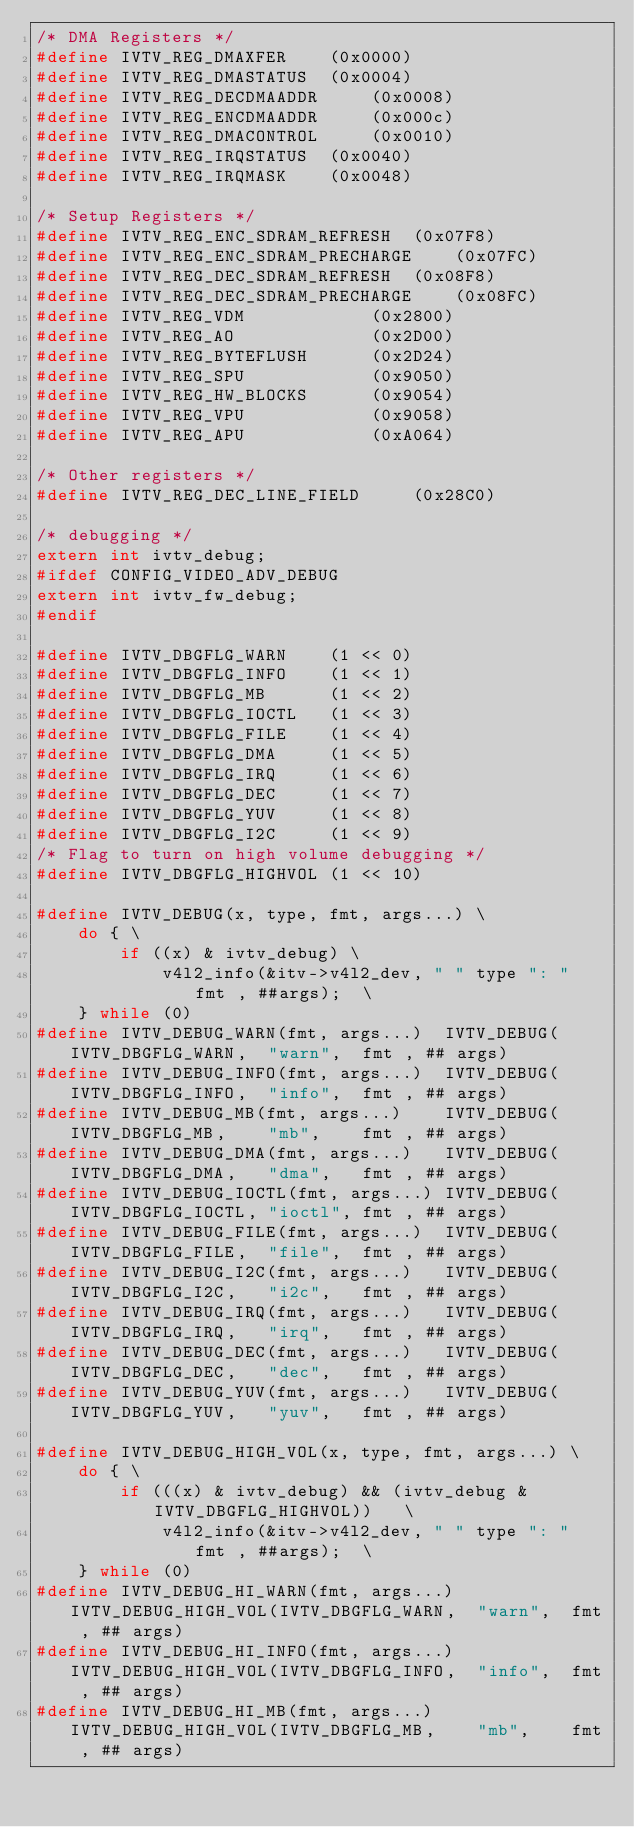Convert code to text. <code><loc_0><loc_0><loc_500><loc_500><_C_>/* DMA Registers */
#define IVTV_REG_DMAXFER 	(0x0000)
#define IVTV_REG_DMASTATUS 	(0x0004)
#define IVTV_REG_DECDMAADDR 	(0x0008)
#define IVTV_REG_ENCDMAADDR 	(0x000c)
#define IVTV_REG_DMACONTROL 	(0x0010)
#define IVTV_REG_IRQSTATUS 	(0x0040)
#define IVTV_REG_IRQMASK 	(0x0048)

/* Setup Registers */
#define IVTV_REG_ENC_SDRAM_REFRESH 	(0x07F8)
#define IVTV_REG_ENC_SDRAM_PRECHARGE 	(0x07FC)
#define IVTV_REG_DEC_SDRAM_REFRESH 	(0x08F8)
#define IVTV_REG_DEC_SDRAM_PRECHARGE 	(0x08FC)
#define IVTV_REG_VDM 			(0x2800)
#define IVTV_REG_AO 			(0x2D00)
#define IVTV_REG_BYTEFLUSH 		(0x2D24)
#define IVTV_REG_SPU 			(0x9050)
#define IVTV_REG_HW_BLOCKS 		(0x9054)
#define IVTV_REG_VPU 			(0x9058)
#define IVTV_REG_APU 			(0xA064)

/* Other registers */
#define IVTV_REG_DEC_LINE_FIELD		(0x28C0)

/* debugging */
extern int ivtv_debug;
#ifdef CONFIG_VIDEO_ADV_DEBUG
extern int ivtv_fw_debug;
#endif

#define IVTV_DBGFLG_WARN    (1 << 0)
#define IVTV_DBGFLG_INFO    (1 << 1)
#define IVTV_DBGFLG_MB      (1 << 2)
#define IVTV_DBGFLG_IOCTL   (1 << 3)
#define IVTV_DBGFLG_FILE    (1 << 4)
#define IVTV_DBGFLG_DMA     (1 << 5)
#define IVTV_DBGFLG_IRQ     (1 << 6)
#define IVTV_DBGFLG_DEC     (1 << 7)
#define IVTV_DBGFLG_YUV     (1 << 8)
#define IVTV_DBGFLG_I2C     (1 << 9)
/* Flag to turn on high volume debugging */
#define IVTV_DBGFLG_HIGHVOL (1 << 10)

#define IVTV_DEBUG(x, type, fmt, args...) \
	do { \
		if ((x) & ivtv_debug) \
			v4l2_info(&itv->v4l2_dev, " " type ": " fmt , ##args);	\
	} while (0)
#define IVTV_DEBUG_WARN(fmt, args...)  IVTV_DEBUG(IVTV_DBGFLG_WARN,  "warn",  fmt , ## args)
#define IVTV_DEBUG_INFO(fmt, args...)  IVTV_DEBUG(IVTV_DBGFLG_INFO,  "info",  fmt , ## args)
#define IVTV_DEBUG_MB(fmt, args...)    IVTV_DEBUG(IVTV_DBGFLG_MB,    "mb",    fmt , ## args)
#define IVTV_DEBUG_DMA(fmt, args...)   IVTV_DEBUG(IVTV_DBGFLG_DMA,   "dma",   fmt , ## args)
#define IVTV_DEBUG_IOCTL(fmt, args...) IVTV_DEBUG(IVTV_DBGFLG_IOCTL, "ioctl", fmt , ## args)
#define IVTV_DEBUG_FILE(fmt, args...)  IVTV_DEBUG(IVTV_DBGFLG_FILE,  "file",  fmt , ## args)
#define IVTV_DEBUG_I2C(fmt, args...)   IVTV_DEBUG(IVTV_DBGFLG_I2C,   "i2c",   fmt , ## args)
#define IVTV_DEBUG_IRQ(fmt, args...)   IVTV_DEBUG(IVTV_DBGFLG_IRQ,   "irq",   fmt , ## args)
#define IVTV_DEBUG_DEC(fmt, args...)   IVTV_DEBUG(IVTV_DBGFLG_DEC,   "dec",   fmt , ## args)
#define IVTV_DEBUG_YUV(fmt, args...)   IVTV_DEBUG(IVTV_DBGFLG_YUV,   "yuv",   fmt , ## args)

#define IVTV_DEBUG_HIGH_VOL(x, type, fmt, args...) \
	do { \
		if (((x) & ivtv_debug) && (ivtv_debug & IVTV_DBGFLG_HIGHVOL)) 	\
			v4l2_info(&itv->v4l2_dev, " " type ": " fmt , ##args);	\
	} while (0)
#define IVTV_DEBUG_HI_WARN(fmt, args...)  IVTV_DEBUG_HIGH_VOL(IVTV_DBGFLG_WARN,  "warn",  fmt , ## args)
#define IVTV_DEBUG_HI_INFO(fmt, args...)  IVTV_DEBUG_HIGH_VOL(IVTV_DBGFLG_INFO,  "info",  fmt , ## args)
#define IVTV_DEBUG_HI_MB(fmt, args...)    IVTV_DEBUG_HIGH_VOL(IVTV_DBGFLG_MB,    "mb",    fmt , ## args)</code> 